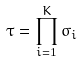<formula> <loc_0><loc_0><loc_500><loc_500>\tau = \prod _ { i = 1 } ^ { K } \sigma _ { i }</formula> 